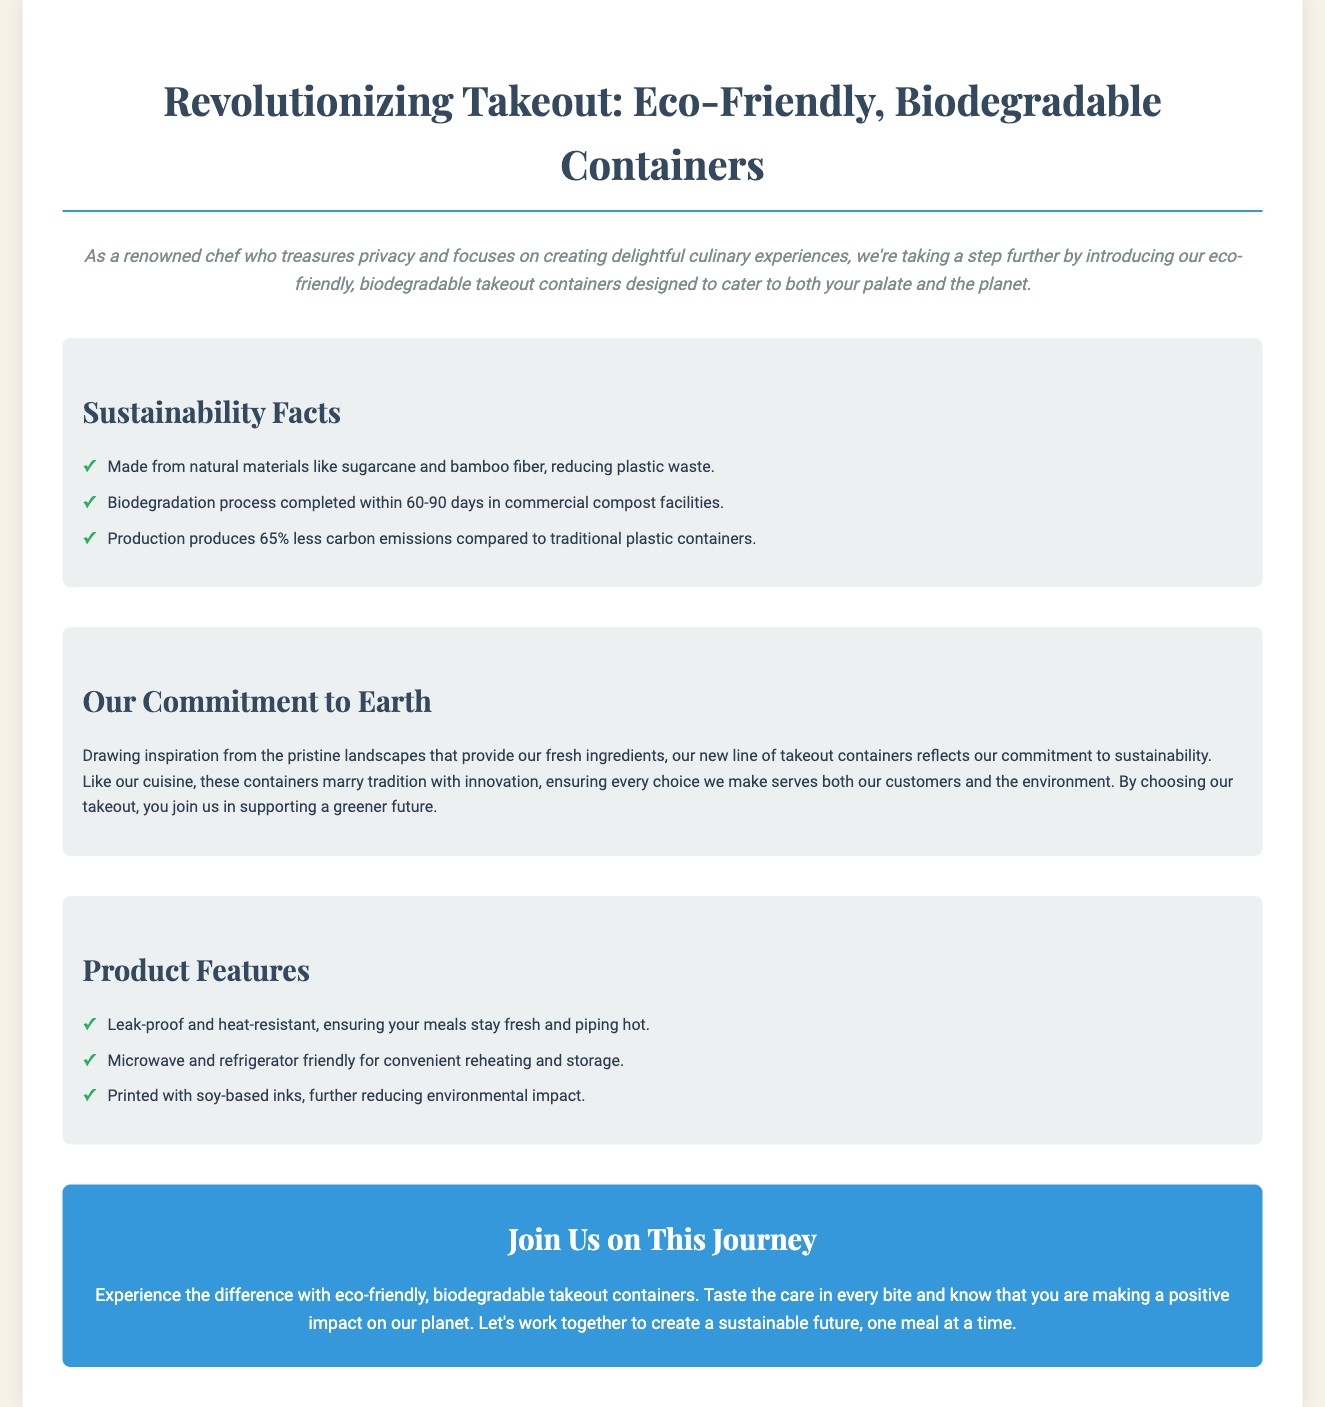What materials are the containers made from? The document states that the containers are made from natural materials like sugarcane and bamboo fiber.
Answer: sugarcane and bamboo fiber How long does the biodegradation process take? The document mentions that the biodegradation process is completed within 60-90 days in commercial compost facilities.
Answer: 60-90 days What percentage less carbon emissions do these containers produce compared to traditional plastic? The document specifies that production produces 65% less carbon emissions compared to traditional plastic containers.
Answer: 65% What feature ensures the meals stay fresh? The document notes that the containers are leak-proof and heat-resistant, ensuring meals stay fresh.
Answer: leak-proof and heat-resistant What type of inks are used for printing? The document mentions that the containers are printed with soy-based inks.
Answer: soy-based inks Why did the company create these containers? The document states that the company aims to reflect its commitment to sustainability and support a greener future.
Answer: support a greener future What is the primary focus of the brand story? The brand story emphasizes a commitment to sustainability inspired by pristine landscapes and fresh ingredients.
Answer: commitment to sustainability What joining call does the document include? The document invites consumers to join in creating a sustainable future, one meal at a time.
Answer: create a sustainable future 